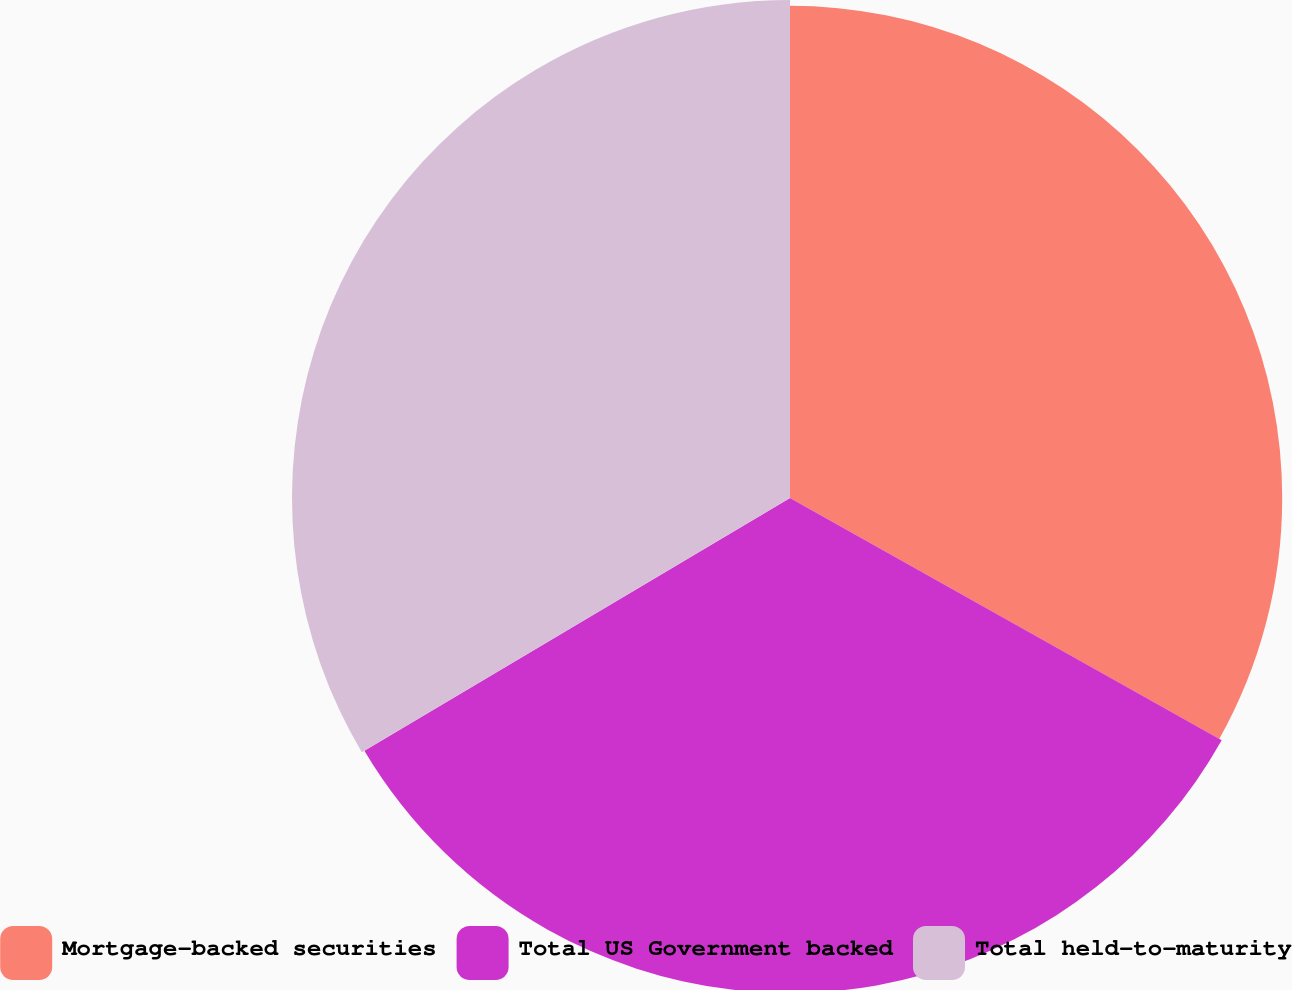Convert chart to OTSL. <chart><loc_0><loc_0><loc_500><loc_500><pie_chart><fcel>Mortgage-backed securities<fcel>Total US Government backed<fcel>Total held-to-maturity<nl><fcel>33.14%<fcel>33.33%<fcel>33.53%<nl></chart> 